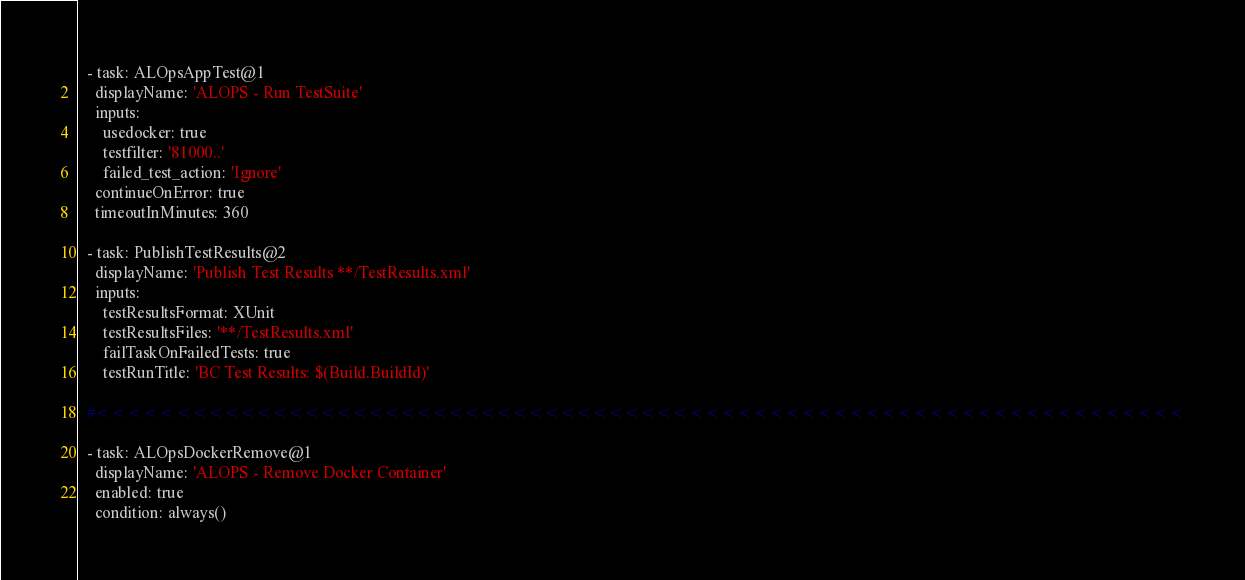<code> <loc_0><loc_0><loc_500><loc_500><_YAML_>  - task: ALOpsAppTest@1
    displayName: 'ALOPS - Run TestSuite'
    inputs:
      usedocker: true
      testfilter: '81000..'
      failed_test_action: 'Ignore'
    continueOnError: true
    timeoutInMinutes: 360

  - task: PublishTestResults@2
    displayName: 'Publish Test Results **/TestResults.xml'
    inputs:
      testResultsFormat: XUnit
      testResultsFiles: '**/TestResults.xml'
      failTaskOnFailedTests: true
      testRunTitle: 'BC Test Results: $(Build.BuildId)'

  #<<<<<<<<<<<<<<<<<<<<<<<<<<<<<<<<<<<<<<<<<<<<<<<<<<<<<<<<<<<<<<<<<<<<

  - task: ALOpsDockerRemove@1
    displayName: 'ALOPS - Remove Docker Container'
    enabled: true
    condition: always()</code> 